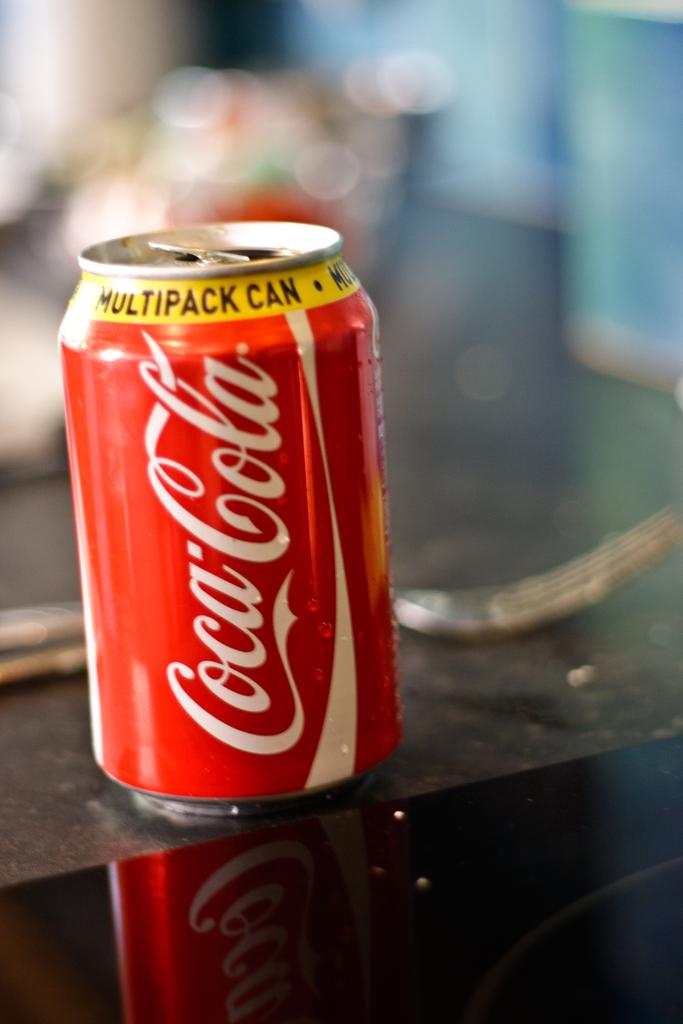<image>
Give a short and clear explanation of the subsequent image. An open can of Coca-Cola sits on the edge of a table. 